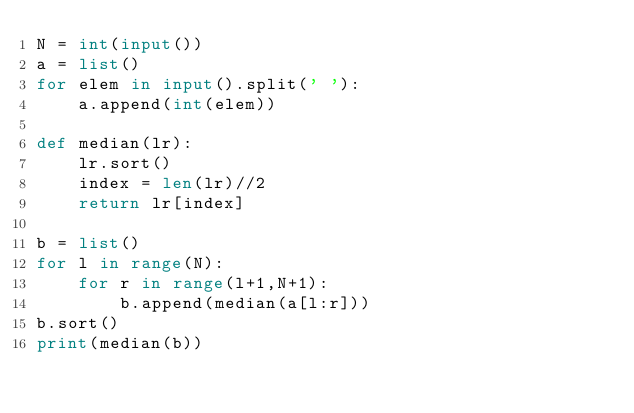Convert code to text. <code><loc_0><loc_0><loc_500><loc_500><_Python_>N = int(input())
a = list()
for elem in input().split(' '):
    a.append(int(elem)) 

def median(lr):
    lr.sort()
    index = len(lr)//2
    return lr[index]

b = list()
for l in range(N):
    for r in range(l+1,N+1):
        b.append(median(a[l:r]))
b.sort()  
print(median(b))
    

</code> 